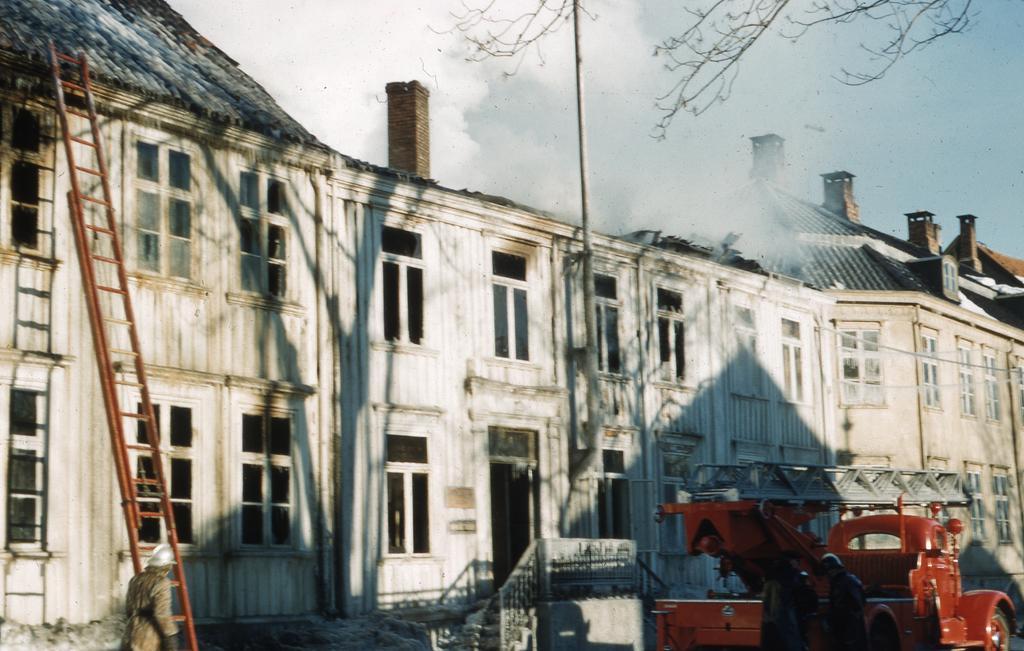Describe this image in one or two sentences. In this image I can see buildings. There is a vehicle and a ladder. There are three persons and in the background there is sky. 